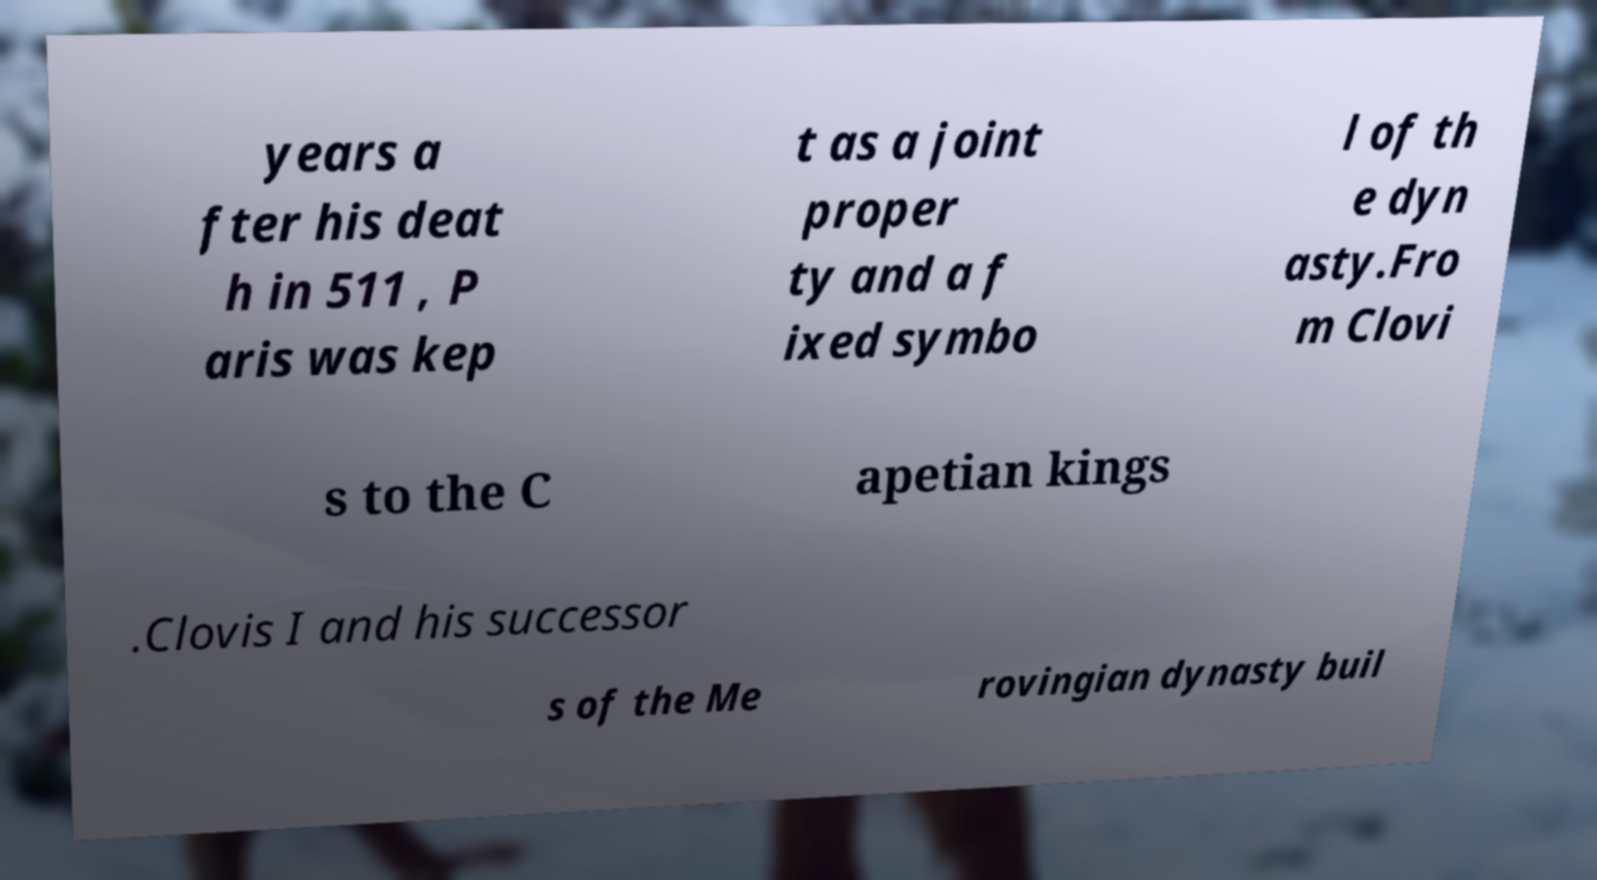I need the written content from this picture converted into text. Can you do that? years a fter his deat h in 511 , P aris was kep t as a joint proper ty and a f ixed symbo l of th e dyn asty.Fro m Clovi s to the C apetian kings .Clovis I and his successor s of the Me rovingian dynasty buil 